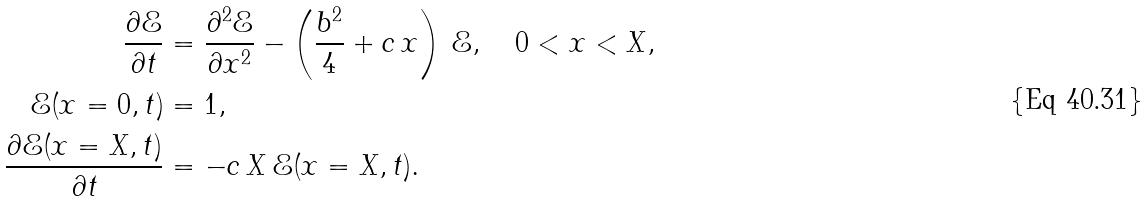Convert formula to latex. <formula><loc_0><loc_0><loc_500><loc_500>\frac { \partial \mathcal { E } } { \partial t } & = \frac { \partial ^ { 2 } \mathcal { E } } { \partial x ^ { 2 } } - \left ( \frac { b ^ { 2 } } { 4 } + c \, x \right ) \, \mathcal { E } , \quad 0 < x < X , \\ \mathcal { E } ( x = 0 , t ) & = 1 , \\ \frac { \partial \mathcal { E } ( x = X , t ) } { \partial t } & = - c \, X \, \mathcal { E } ( x = X , t ) .</formula> 